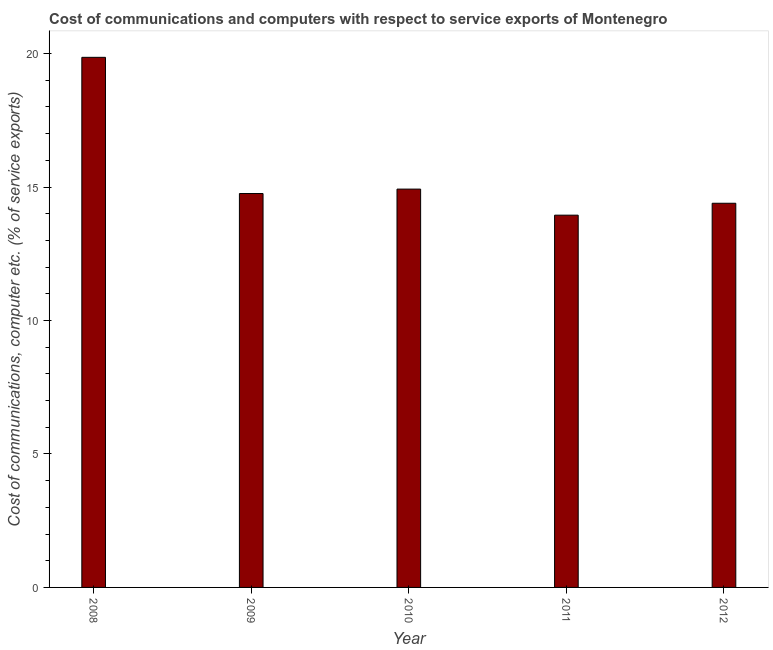Does the graph contain grids?
Keep it short and to the point. No. What is the title of the graph?
Provide a short and direct response. Cost of communications and computers with respect to service exports of Montenegro. What is the label or title of the X-axis?
Offer a terse response. Year. What is the label or title of the Y-axis?
Your answer should be compact. Cost of communications, computer etc. (% of service exports). What is the cost of communications and computer in 2012?
Give a very brief answer. 14.39. Across all years, what is the maximum cost of communications and computer?
Your answer should be very brief. 19.86. Across all years, what is the minimum cost of communications and computer?
Your answer should be compact. 13.95. In which year was the cost of communications and computer maximum?
Make the answer very short. 2008. In which year was the cost of communications and computer minimum?
Your answer should be very brief. 2011. What is the sum of the cost of communications and computer?
Give a very brief answer. 77.88. What is the difference between the cost of communications and computer in 2010 and 2012?
Keep it short and to the point. 0.53. What is the average cost of communications and computer per year?
Keep it short and to the point. 15.58. What is the median cost of communications and computer?
Make the answer very short. 14.76. In how many years, is the cost of communications and computer greater than 8 %?
Offer a terse response. 5. What is the ratio of the cost of communications and computer in 2008 to that in 2010?
Offer a very short reply. 1.33. Is the cost of communications and computer in 2008 less than that in 2009?
Your answer should be compact. No. Is the difference between the cost of communications and computer in 2009 and 2011 greater than the difference between any two years?
Your answer should be very brief. No. What is the difference between the highest and the second highest cost of communications and computer?
Your response must be concise. 4.94. What is the difference between the highest and the lowest cost of communications and computer?
Keep it short and to the point. 5.91. Are all the bars in the graph horizontal?
Make the answer very short. No. What is the difference between two consecutive major ticks on the Y-axis?
Make the answer very short. 5. What is the Cost of communications, computer etc. (% of service exports) in 2008?
Keep it short and to the point. 19.86. What is the Cost of communications, computer etc. (% of service exports) in 2009?
Your answer should be very brief. 14.76. What is the Cost of communications, computer etc. (% of service exports) in 2010?
Make the answer very short. 14.92. What is the Cost of communications, computer etc. (% of service exports) in 2011?
Offer a terse response. 13.95. What is the Cost of communications, computer etc. (% of service exports) of 2012?
Offer a very short reply. 14.39. What is the difference between the Cost of communications, computer etc. (% of service exports) in 2008 and 2009?
Ensure brevity in your answer.  5.1. What is the difference between the Cost of communications, computer etc. (% of service exports) in 2008 and 2010?
Your answer should be very brief. 4.94. What is the difference between the Cost of communications, computer etc. (% of service exports) in 2008 and 2011?
Your answer should be very brief. 5.91. What is the difference between the Cost of communications, computer etc. (% of service exports) in 2008 and 2012?
Your answer should be very brief. 5.47. What is the difference between the Cost of communications, computer etc. (% of service exports) in 2009 and 2010?
Keep it short and to the point. -0.17. What is the difference between the Cost of communications, computer etc. (% of service exports) in 2009 and 2011?
Make the answer very short. 0.81. What is the difference between the Cost of communications, computer etc. (% of service exports) in 2009 and 2012?
Offer a very short reply. 0.36. What is the difference between the Cost of communications, computer etc. (% of service exports) in 2010 and 2011?
Offer a very short reply. 0.98. What is the difference between the Cost of communications, computer etc. (% of service exports) in 2010 and 2012?
Keep it short and to the point. 0.53. What is the difference between the Cost of communications, computer etc. (% of service exports) in 2011 and 2012?
Offer a terse response. -0.45. What is the ratio of the Cost of communications, computer etc. (% of service exports) in 2008 to that in 2009?
Provide a succinct answer. 1.35. What is the ratio of the Cost of communications, computer etc. (% of service exports) in 2008 to that in 2010?
Your response must be concise. 1.33. What is the ratio of the Cost of communications, computer etc. (% of service exports) in 2008 to that in 2011?
Provide a succinct answer. 1.42. What is the ratio of the Cost of communications, computer etc. (% of service exports) in 2008 to that in 2012?
Your answer should be compact. 1.38. What is the ratio of the Cost of communications, computer etc. (% of service exports) in 2009 to that in 2011?
Your answer should be compact. 1.06. What is the ratio of the Cost of communications, computer etc. (% of service exports) in 2010 to that in 2011?
Provide a short and direct response. 1.07. 